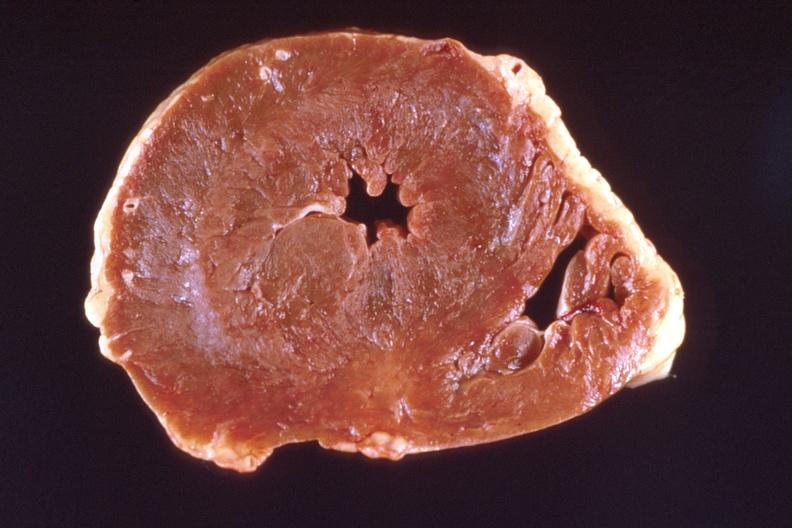s cardiovascular present?
Answer the question using a single word or phrase. Yes 